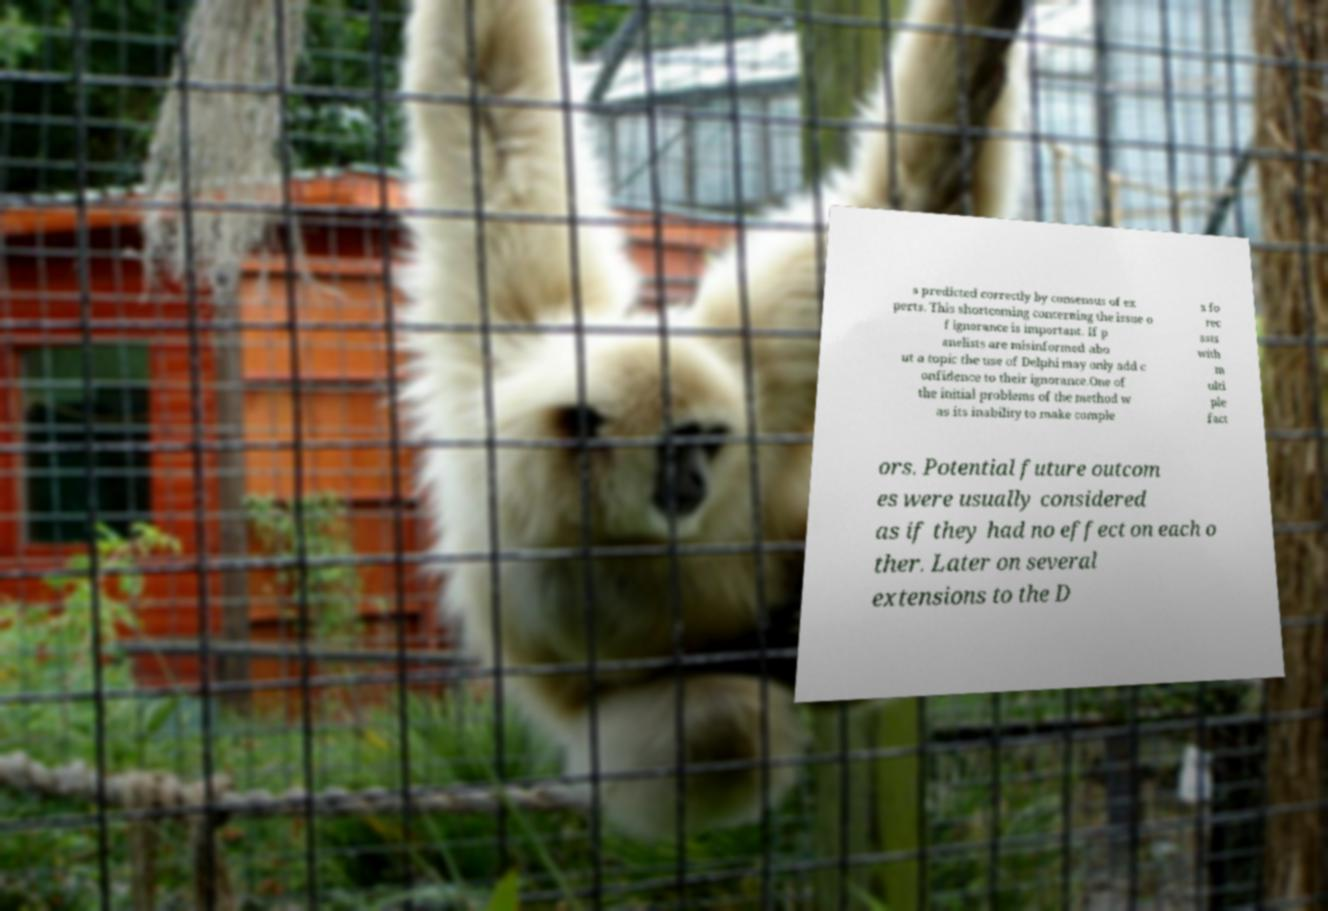Could you extract and type out the text from this image? s predicted correctly by consensus of ex perts. This shortcoming concerning the issue o f ignorance is important. If p anelists are misinformed abo ut a topic the use of Delphi may only add c onfidence to their ignorance.One of the initial problems of the method w as its inability to make comple x fo rec asts with m ulti ple fact ors. Potential future outcom es were usually considered as if they had no effect on each o ther. Later on several extensions to the D 